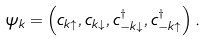<formula> <loc_0><loc_0><loc_500><loc_500>\psi _ { k } = \left ( c _ { { k } \uparrow } , c _ { { k } \downarrow } , c ^ { \dagger } _ { - { k } \downarrow } , c ^ { \dagger } _ { - { k } \uparrow } \right ) .</formula> 